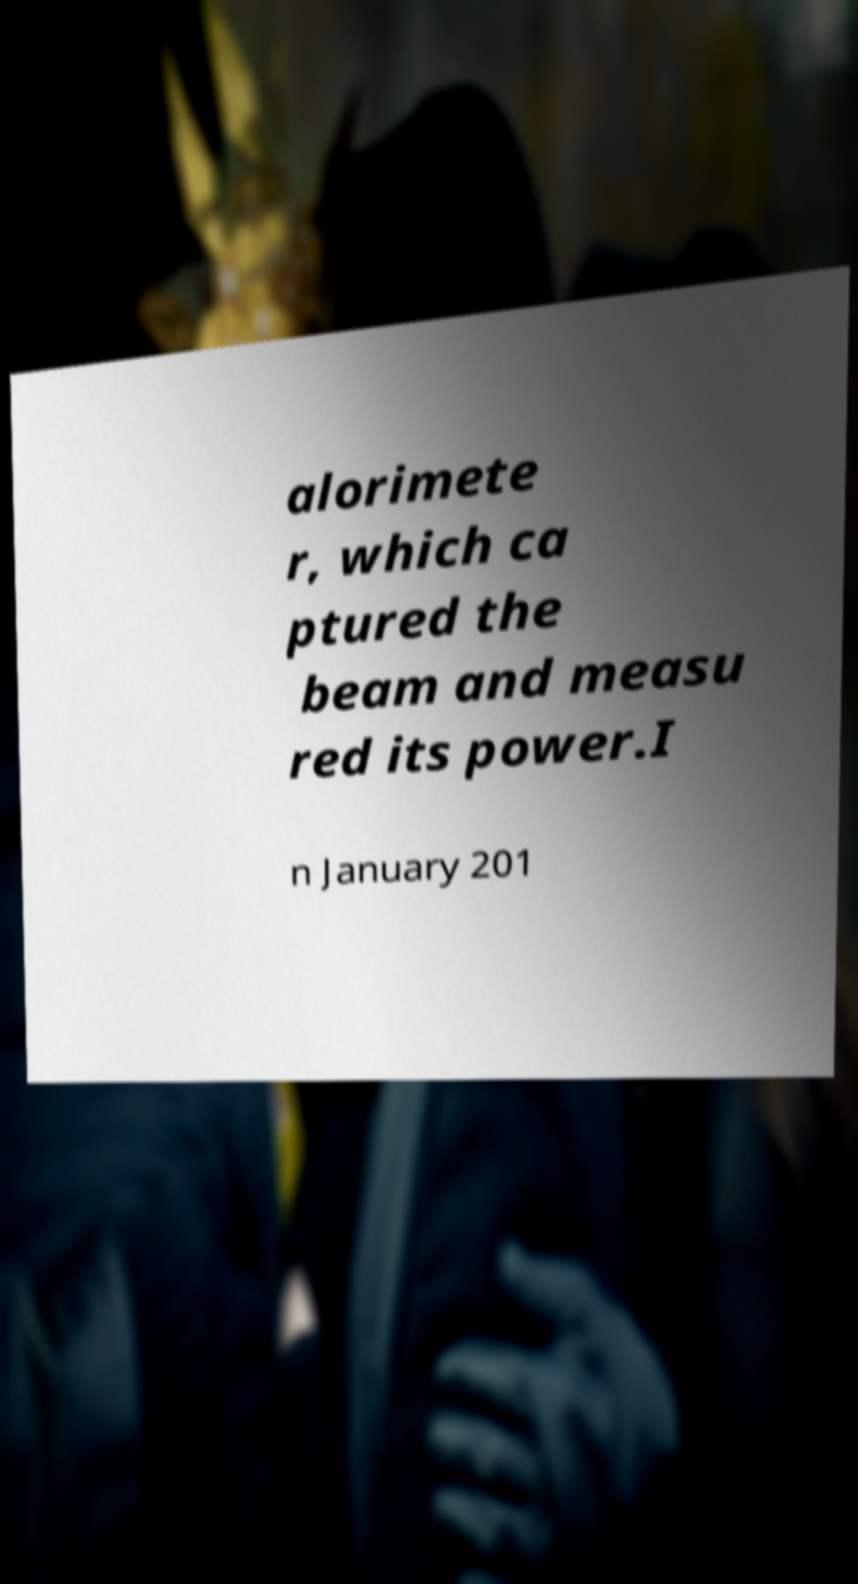For documentation purposes, I need the text within this image transcribed. Could you provide that? alorimete r, which ca ptured the beam and measu red its power.I n January 201 